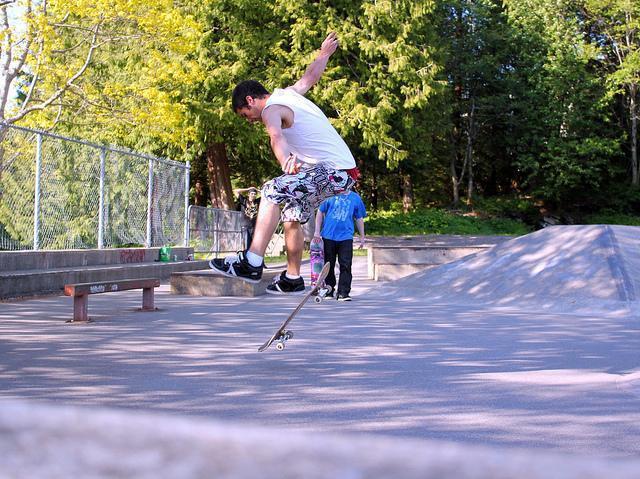How many people are visible?
Give a very brief answer. 2. 